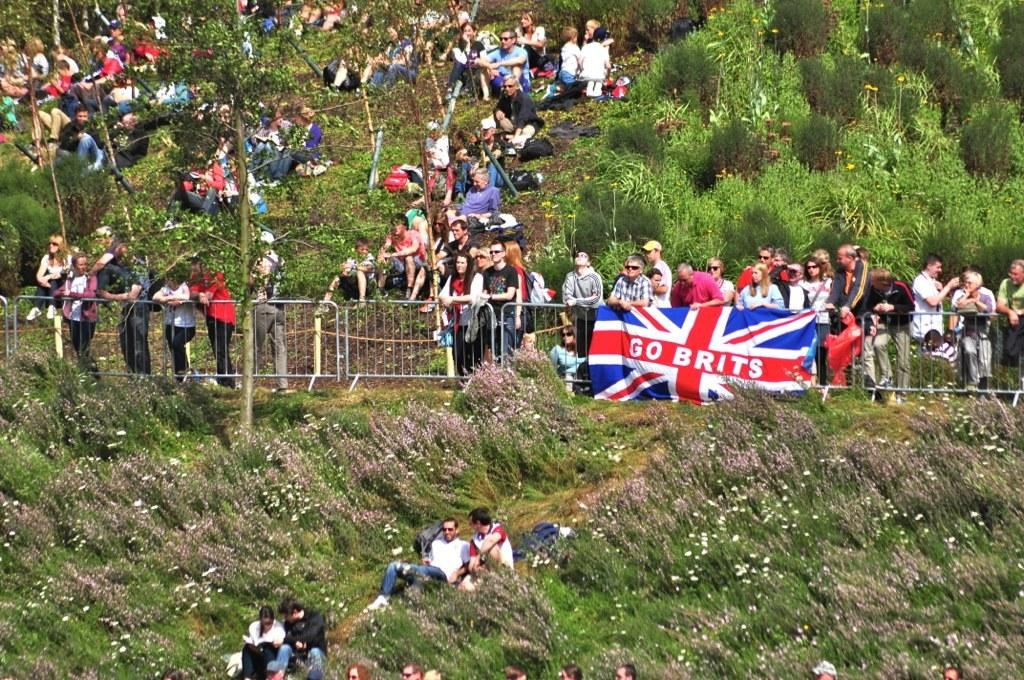How many people are in the image? There is a group of people in the image, but the exact number cannot be determined from the provided facts. What can be seen in the background of the image? There is a fence, a flag, plants with flowers, and a group of trees in the image. What type of plants are present in the image? The plants with flowers are present in the image. Are there any masks being worn by the people in the image? There is no mention of masks in the provided facts, so we cannot determine if any masks are being worn in the image. 